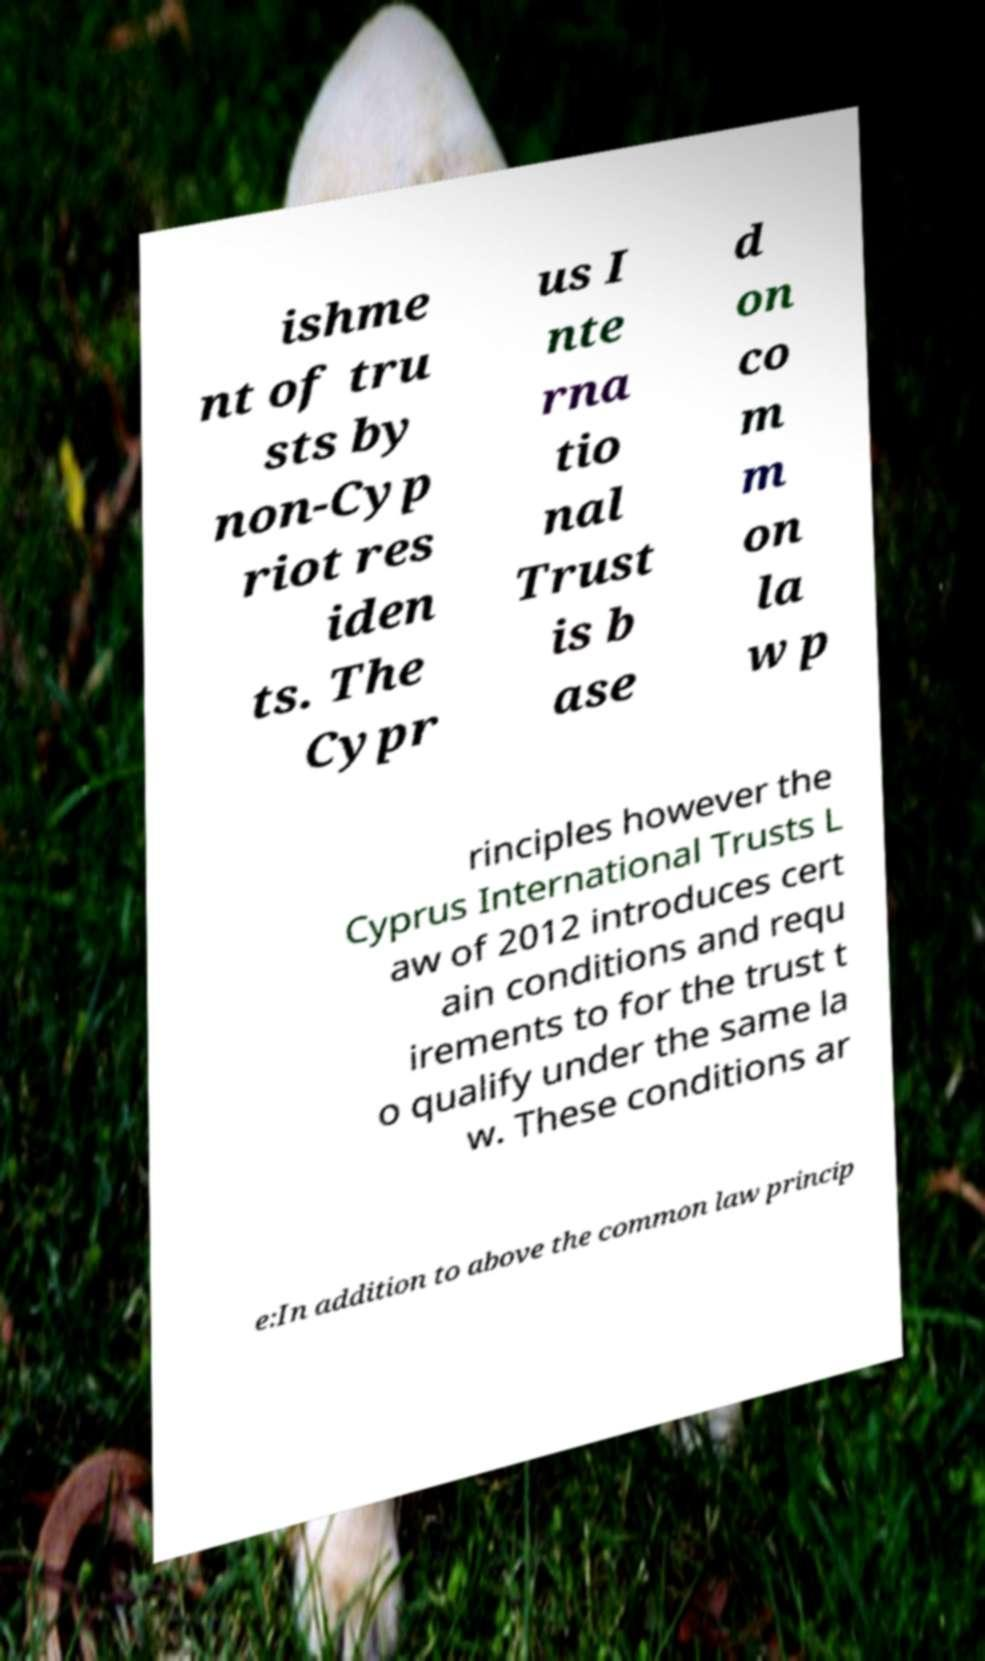For documentation purposes, I need the text within this image transcribed. Could you provide that? ishme nt of tru sts by non-Cyp riot res iden ts. The Cypr us I nte rna tio nal Trust is b ase d on co m m on la w p rinciples however the Cyprus International Trusts L aw of 2012 introduces cert ain conditions and requ irements to for the trust t o qualify under the same la w. These conditions ar e:In addition to above the common law princip 